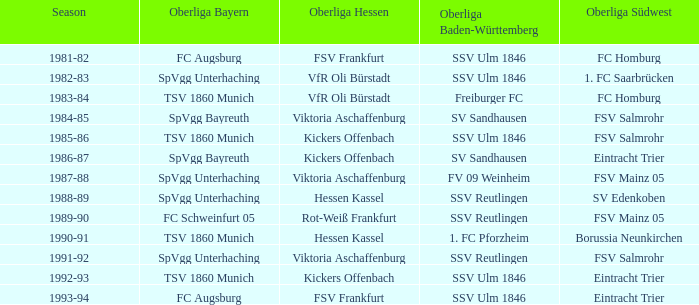Which Oberliga Südwest has an Oberliga Bayern of fc schweinfurt 05? FSV Mainz 05. 